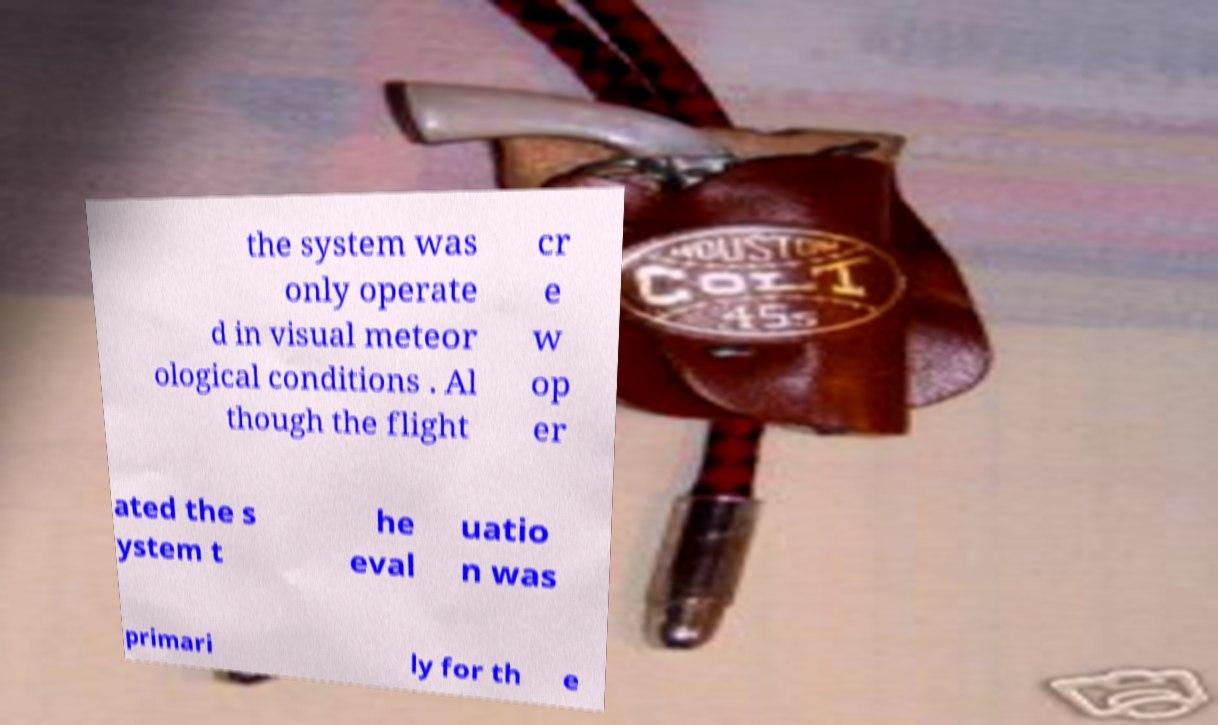There's text embedded in this image that I need extracted. Can you transcribe it verbatim? the system was only operate d in visual meteor ological conditions . Al though the flight cr e w op er ated the s ystem t he eval uatio n was primari ly for th e 